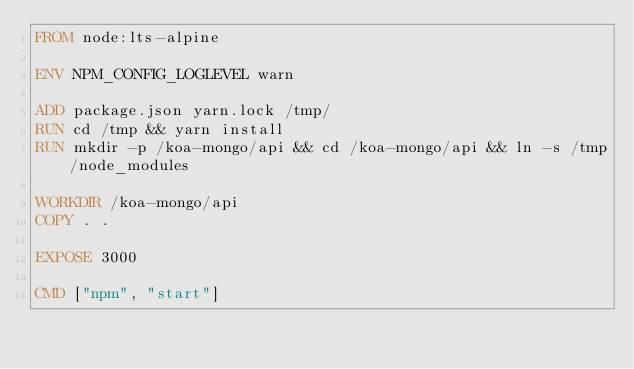<code> <loc_0><loc_0><loc_500><loc_500><_Dockerfile_>FROM node:lts-alpine

ENV NPM_CONFIG_LOGLEVEL warn

ADD package.json yarn.lock /tmp/
RUN cd /tmp && yarn install
RUN mkdir -p /koa-mongo/api && cd /koa-mongo/api && ln -s /tmp/node_modules

WORKDIR /koa-mongo/api
COPY . .

EXPOSE 3000

CMD ["npm", "start"]
</code> 